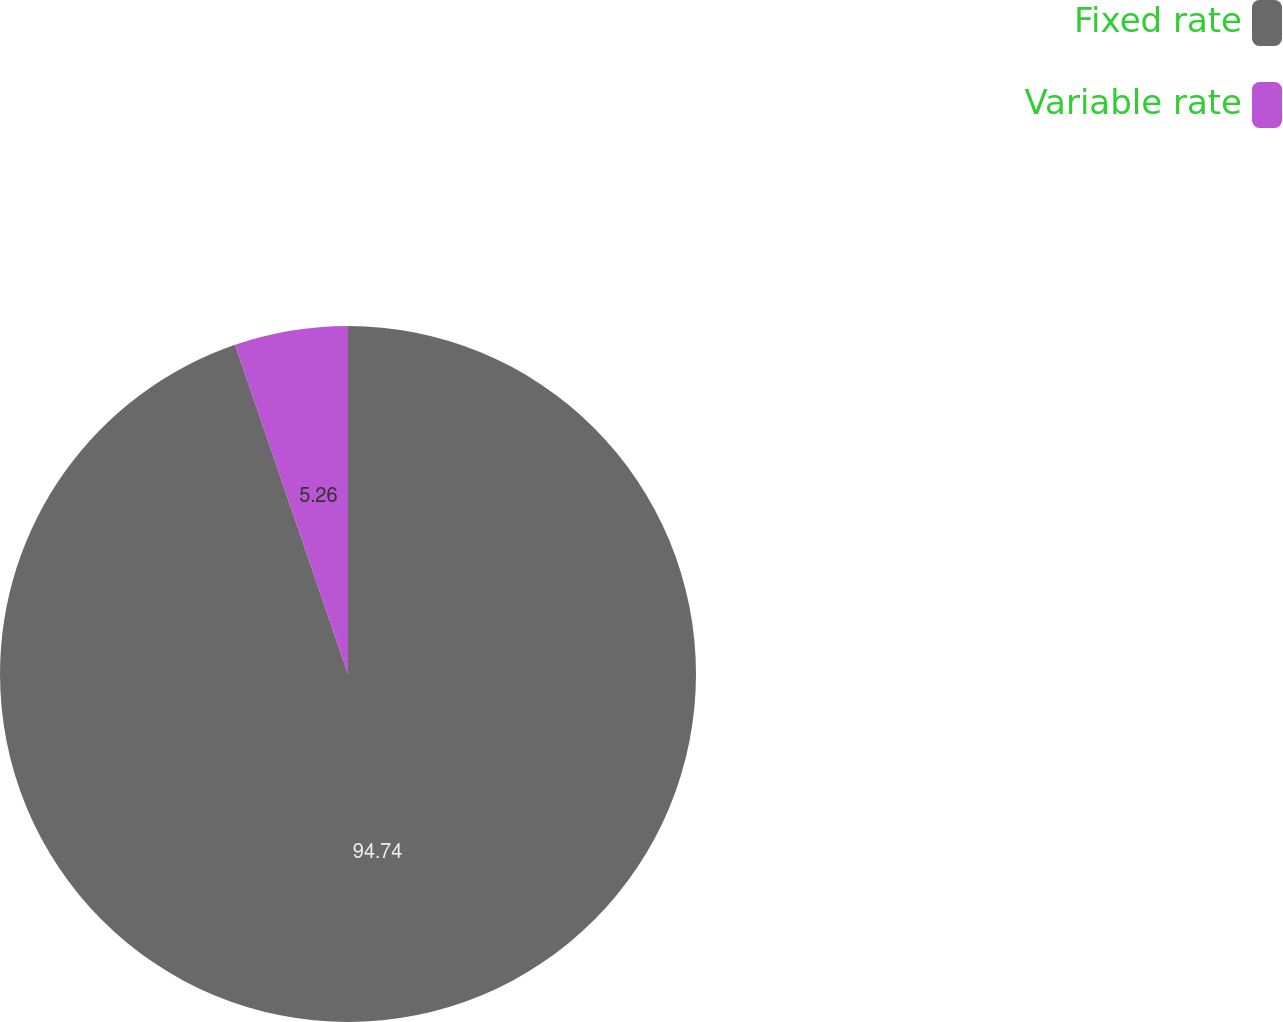Convert chart to OTSL. <chart><loc_0><loc_0><loc_500><loc_500><pie_chart><fcel>Fixed rate<fcel>Variable rate<nl><fcel>94.74%<fcel>5.26%<nl></chart> 